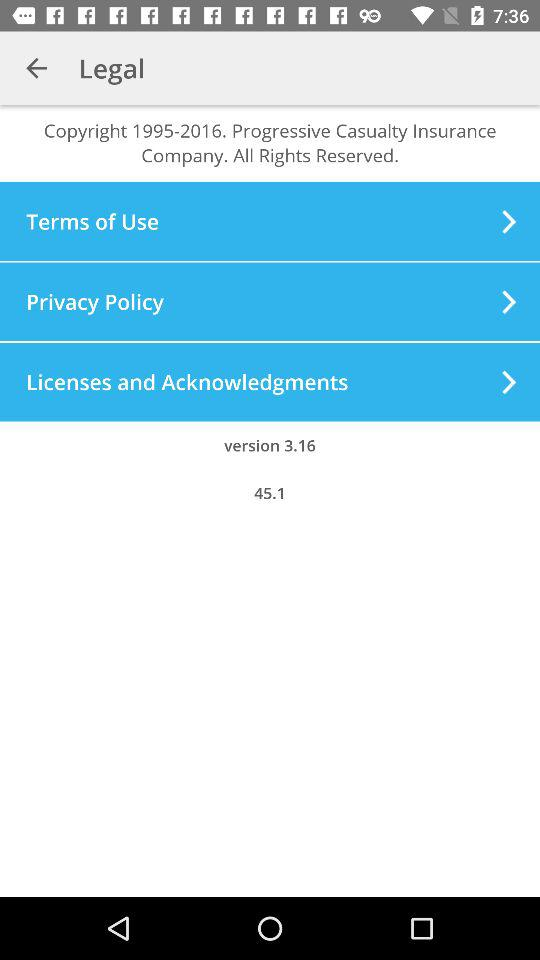What is the copyright year range? The copyright year range is from 1995 to 2016. 